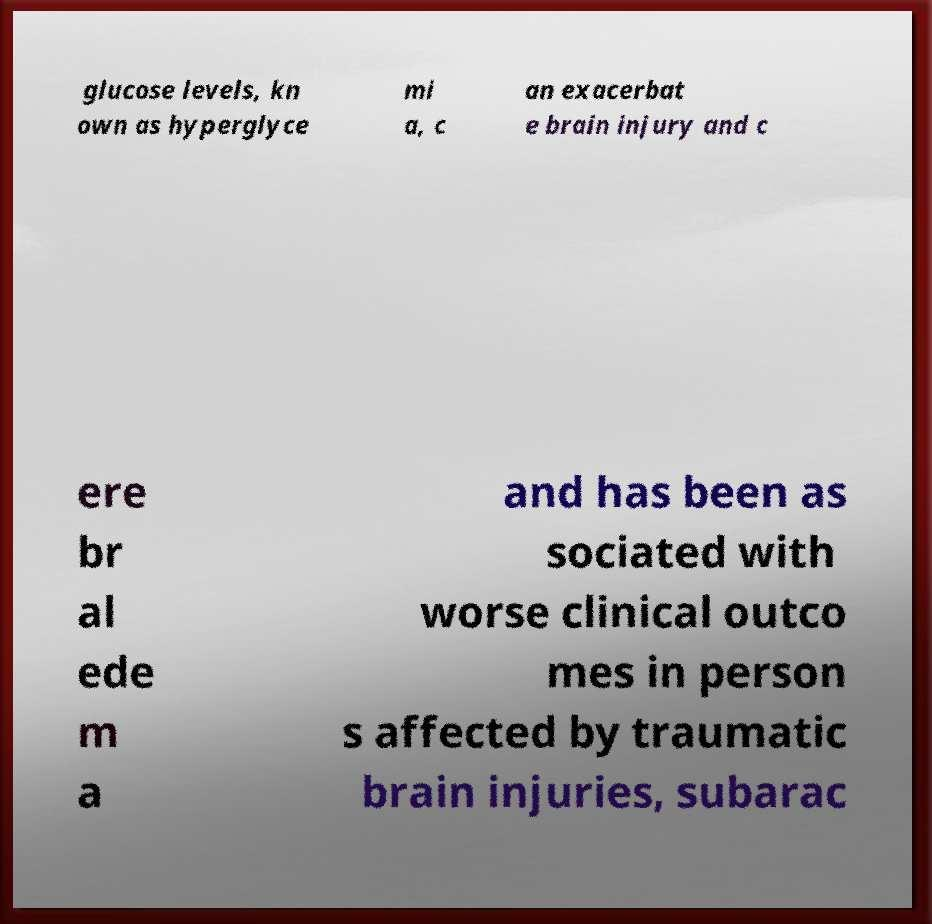I need the written content from this picture converted into text. Can you do that? glucose levels, kn own as hyperglyce mi a, c an exacerbat e brain injury and c ere br al ede m a and has been as sociated with worse clinical outco mes in person s affected by traumatic brain injuries, subarac 